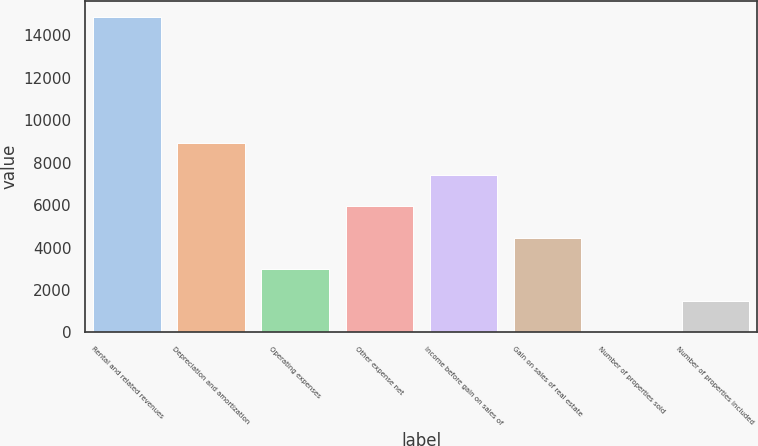Convert chart. <chart><loc_0><loc_0><loc_500><loc_500><bar_chart><fcel>Rental and related revenues<fcel>Depreciation and amortization<fcel>Operating expenses<fcel>Other expense net<fcel>Income before gain on sales of<fcel>Gain on sales of real estate<fcel>Number of properties sold<fcel>Number of properties included<nl><fcel>14877<fcel>8927.4<fcel>2977.8<fcel>5952.6<fcel>7440<fcel>4465.2<fcel>3<fcel>1490.4<nl></chart> 